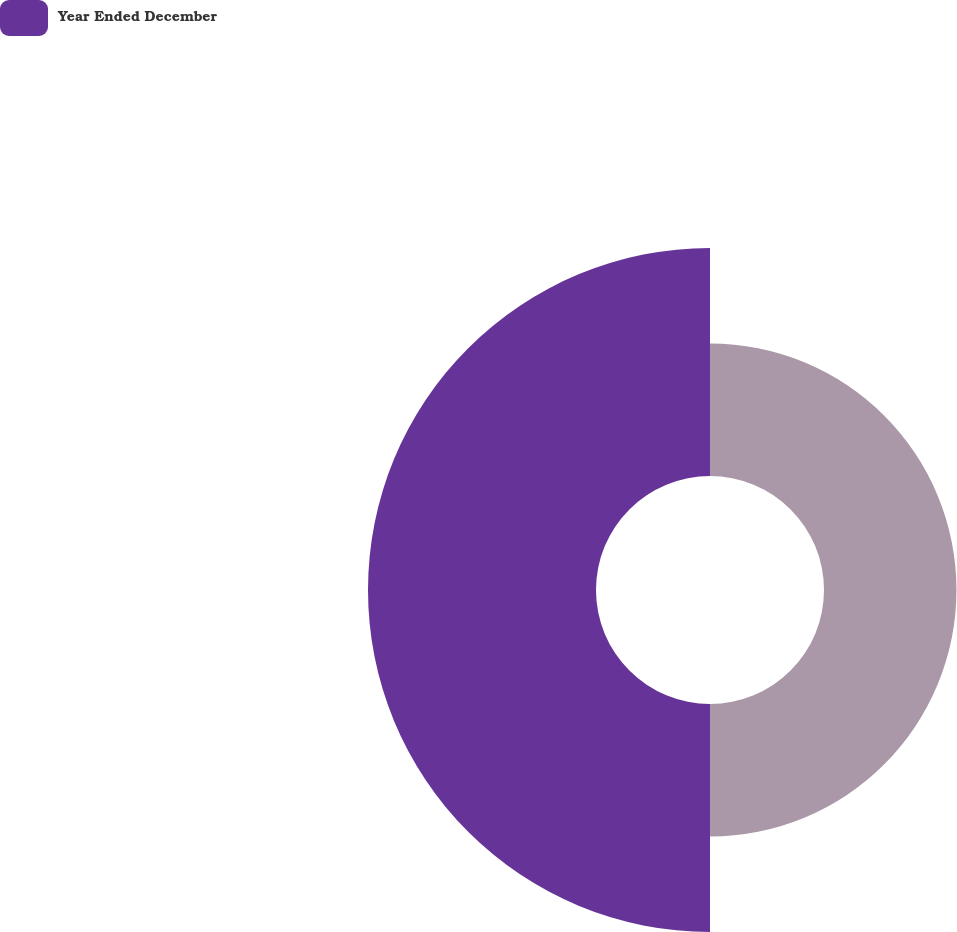<chart> <loc_0><loc_0><loc_500><loc_500><pie_chart><ecel><fcel>Year Ended December<nl><fcel>36.75%<fcel>63.25%<nl></chart> 